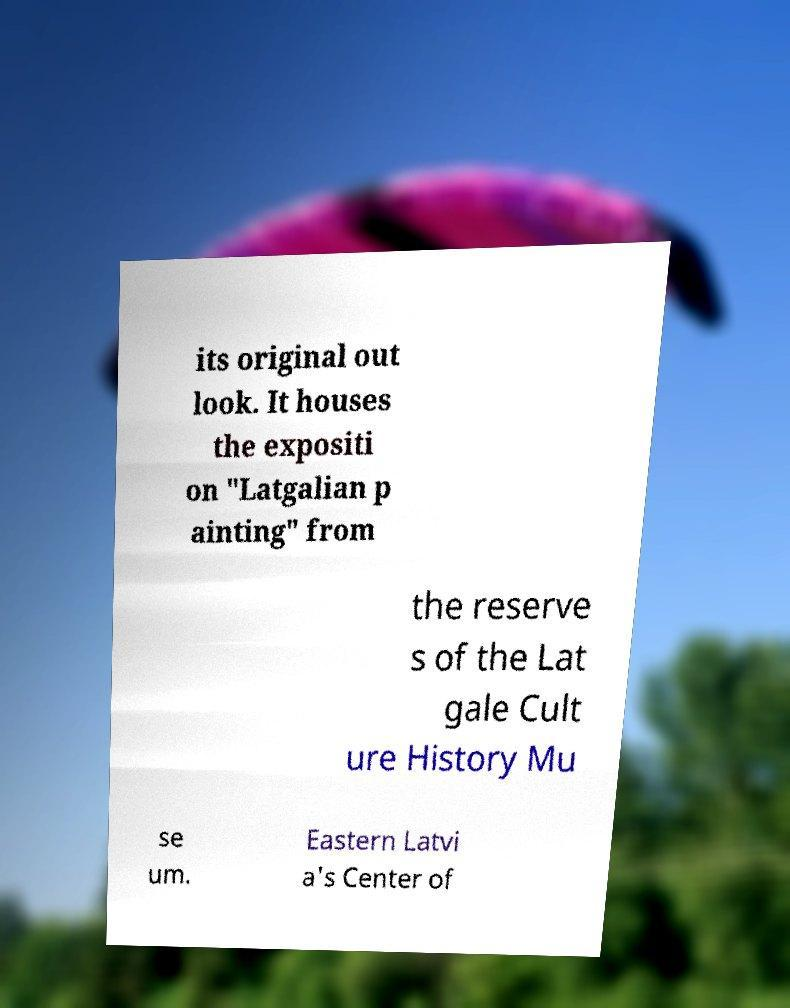Please identify and transcribe the text found in this image. its original out look. It houses the expositi on "Latgalian p ainting" from the reserve s of the Lat gale Cult ure History Mu se um. Eastern Latvi a's Center of 